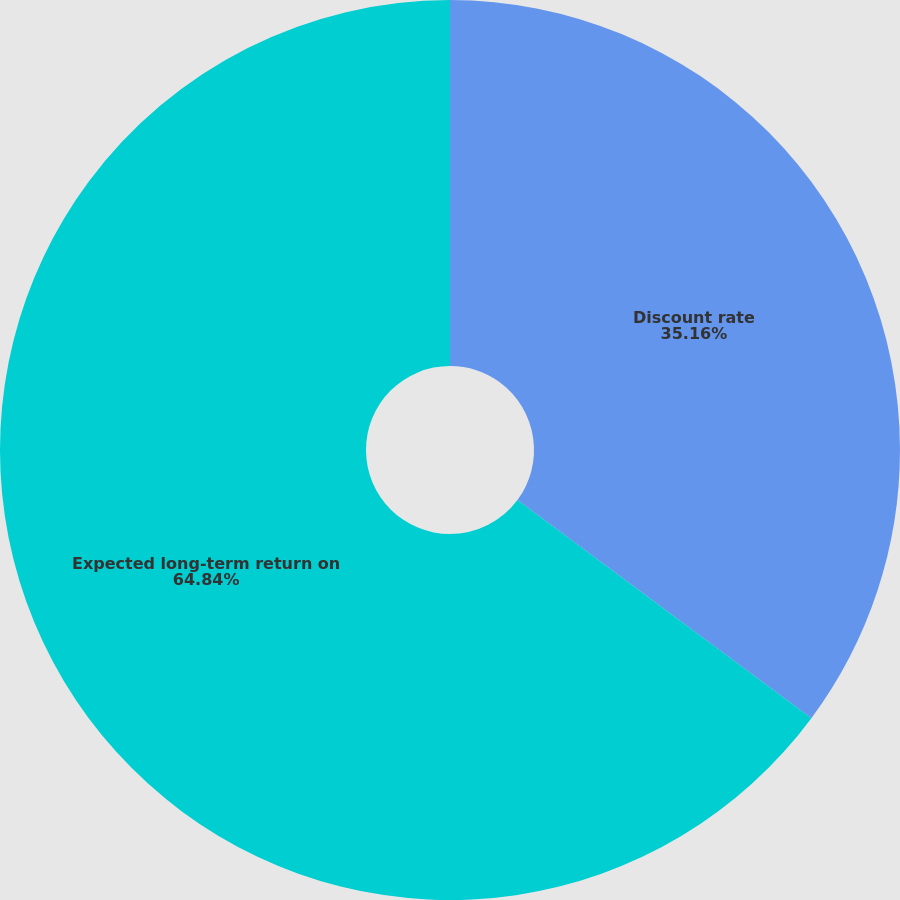Convert chart. <chart><loc_0><loc_0><loc_500><loc_500><pie_chart><fcel>Discount rate<fcel>Expected long-term return on<nl><fcel>35.16%<fcel>64.84%<nl></chart> 